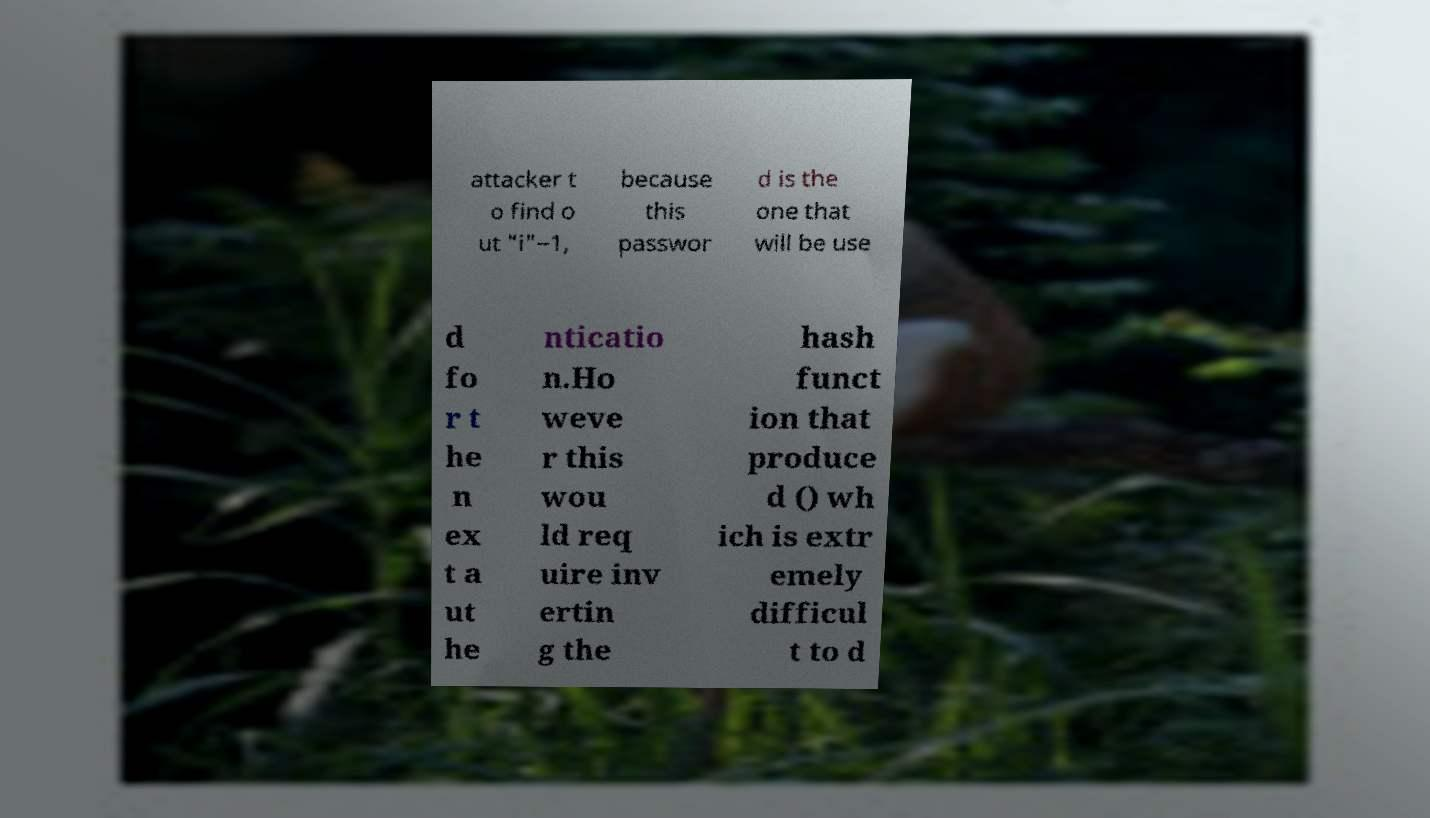Can you accurately transcribe the text from the provided image for me? attacker t o find o ut "i"−1, because this passwor d is the one that will be use d fo r t he n ex t a ut he nticatio n.Ho weve r this wou ld req uire inv ertin g the hash funct ion that produce d () wh ich is extr emely difficul t to d 